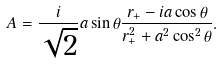Convert formula to latex. <formula><loc_0><loc_0><loc_500><loc_500>A = \frac { i } { \sqrt { 2 } } a \sin \theta \frac { r _ { + } - i a \cos \theta } { r _ { + } ^ { 2 } + a ^ { 2 } \cos ^ { 2 } \theta } .</formula> 